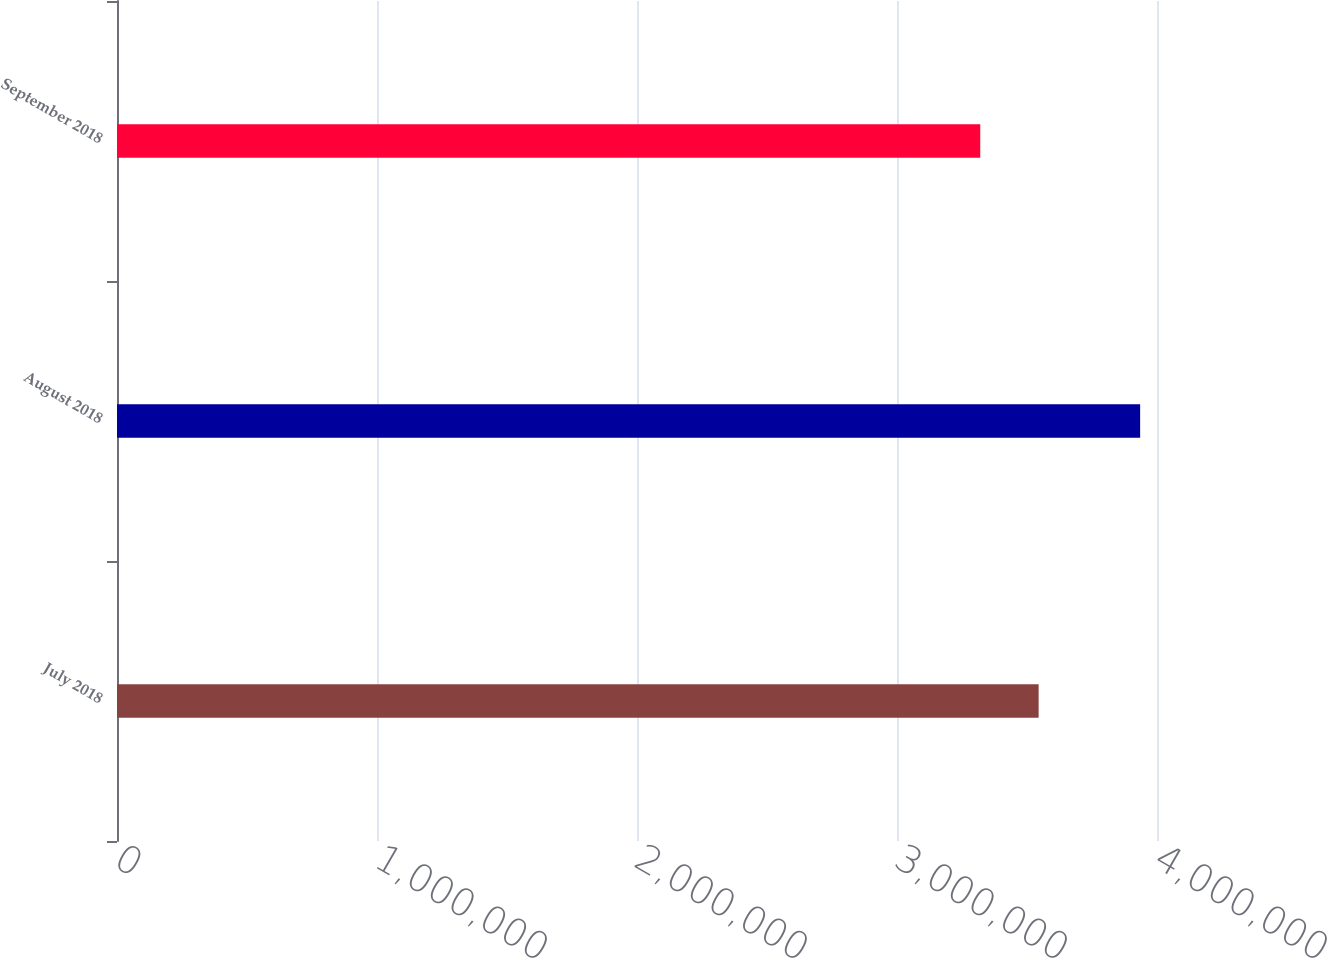Convert chart. <chart><loc_0><loc_0><loc_500><loc_500><bar_chart><fcel>July 2018<fcel>August 2018<fcel>September 2018<nl><fcel>3.54476e+06<fcel>3.93517e+06<fcel>3.32017e+06<nl></chart> 